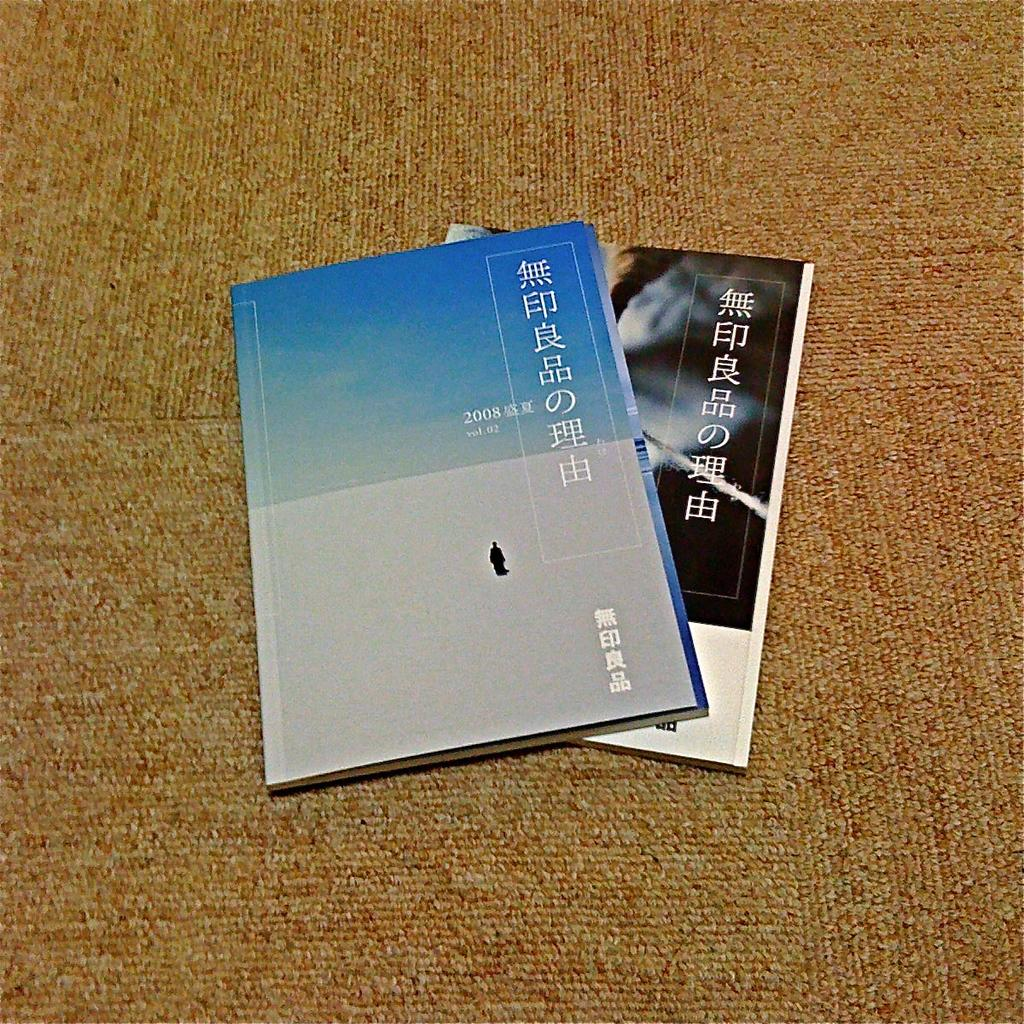<image>
Create a compact narrative representing the image presented. Two pamphlets with a Chinese letters and the year 2008. 